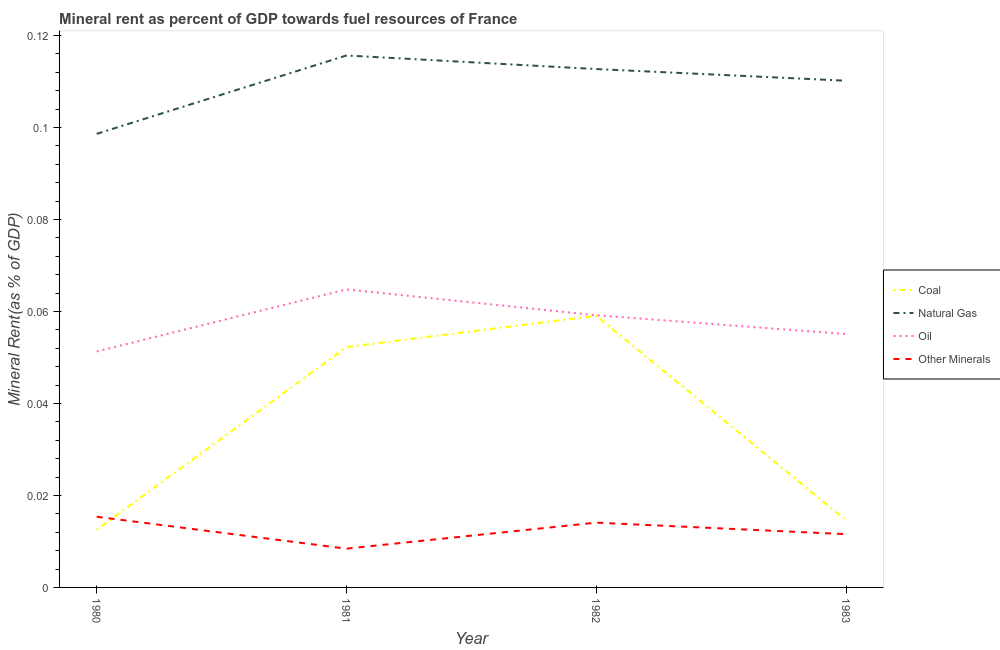How many different coloured lines are there?
Your answer should be compact. 4. Does the line corresponding to coal rent intersect with the line corresponding to oil rent?
Offer a very short reply. No. What is the coal rent in 1983?
Your answer should be compact. 0.01. Across all years, what is the maximum coal rent?
Make the answer very short. 0.06. Across all years, what is the minimum natural gas rent?
Your answer should be compact. 0.1. What is the total natural gas rent in the graph?
Make the answer very short. 0.44. What is the difference between the natural gas rent in 1981 and that in 1982?
Your response must be concise. 0. What is the difference between the natural gas rent in 1982 and the  rent of other minerals in 1981?
Provide a succinct answer. 0.1. What is the average oil rent per year?
Your answer should be very brief. 0.06. In the year 1982, what is the difference between the coal rent and  rent of other minerals?
Make the answer very short. 0.04. In how many years, is the coal rent greater than 0.052000000000000005 %?
Your answer should be compact. 2. What is the ratio of the  rent of other minerals in 1980 to that in 1983?
Provide a short and direct response. 1.33. Is the  rent of other minerals in 1980 less than that in 1983?
Ensure brevity in your answer.  No. What is the difference between the highest and the second highest coal rent?
Offer a very short reply. 0.01. What is the difference between the highest and the lowest coal rent?
Make the answer very short. 0.05. In how many years, is the natural gas rent greater than the average natural gas rent taken over all years?
Offer a very short reply. 3. Is it the case that in every year, the sum of the coal rent and natural gas rent is greater than the oil rent?
Make the answer very short. Yes. Does the coal rent monotonically increase over the years?
Make the answer very short. No. How many years are there in the graph?
Provide a succinct answer. 4. Does the graph contain any zero values?
Your response must be concise. No. Where does the legend appear in the graph?
Offer a terse response. Center right. How many legend labels are there?
Keep it short and to the point. 4. What is the title of the graph?
Ensure brevity in your answer.  Mineral rent as percent of GDP towards fuel resources of France. Does "Management rating" appear as one of the legend labels in the graph?
Provide a short and direct response. No. What is the label or title of the X-axis?
Ensure brevity in your answer.  Year. What is the label or title of the Y-axis?
Keep it short and to the point. Mineral Rent(as % of GDP). What is the Mineral Rent(as % of GDP) in Coal in 1980?
Keep it short and to the point. 0.01. What is the Mineral Rent(as % of GDP) in Natural Gas in 1980?
Make the answer very short. 0.1. What is the Mineral Rent(as % of GDP) of Oil in 1980?
Your response must be concise. 0.05. What is the Mineral Rent(as % of GDP) in Other Minerals in 1980?
Your response must be concise. 0.02. What is the Mineral Rent(as % of GDP) of Coal in 1981?
Provide a short and direct response. 0.05. What is the Mineral Rent(as % of GDP) of Natural Gas in 1981?
Provide a succinct answer. 0.12. What is the Mineral Rent(as % of GDP) in Oil in 1981?
Give a very brief answer. 0.06. What is the Mineral Rent(as % of GDP) of Other Minerals in 1981?
Your answer should be very brief. 0.01. What is the Mineral Rent(as % of GDP) in Coal in 1982?
Your response must be concise. 0.06. What is the Mineral Rent(as % of GDP) of Natural Gas in 1982?
Make the answer very short. 0.11. What is the Mineral Rent(as % of GDP) of Oil in 1982?
Make the answer very short. 0.06. What is the Mineral Rent(as % of GDP) in Other Minerals in 1982?
Your answer should be very brief. 0.01. What is the Mineral Rent(as % of GDP) in Coal in 1983?
Your answer should be very brief. 0.01. What is the Mineral Rent(as % of GDP) in Natural Gas in 1983?
Provide a short and direct response. 0.11. What is the Mineral Rent(as % of GDP) of Oil in 1983?
Provide a short and direct response. 0.06. What is the Mineral Rent(as % of GDP) in Other Minerals in 1983?
Your answer should be compact. 0.01. Across all years, what is the maximum Mineral Rent(as % of GDP) in Coal?
Provide a succinct answer. 0.06. Across all years, what is the maximum Mineral Rent(as % of GDP) of Natural Gas?
Offer a very short reply. 0.12. Across all years, what is the maximum Mineral Rent(as % of GDP) of Oil?
Your response must be concise. 0.06. Across all years, what is the maximum Mineral Rent(as % of GDP) in Other Minerals?
Offer a terse response. 0.02. Across all years, what is the minimum Mineral Rent(as % of GDP) of Coal?
Give a very brief answer. 0.01. Across all years, what is the minimum Mineral Rent(as % of GDP) in Natural Gas?
Keep it short and to the point. 0.1. Across all years, what is the minimum Mineral Rent(as % of GDP) of Oil?
Give a very brief answer. 0.05. Across all years, what is the minimum Mineral Rent(as % of GDP) in Other Minerals?
Keep it short and to the point. 0.01. What is the total Mineral Rent(as % of GDP) of Coal in the graph?
Your answer should be compact. 0.14. What is the total Mineral Rent(as % of GDP) of Natural Gas in the graph?
Keep it short and to the point. 0.44. What is the total Mineral Rent(as % of GDP) of Oil in the graph?
Ensure brevity in your answer.  0.23. What is the total Mineral Rent(as % of GDP) in Other Minerals in the graph?
Give a very brief answer. 0.05. What is the difference between the Mineral Rent(as % of GDP) in Coal in 1980 and that in 1981?
Offer a terse response. -0.04. What is the difference between the Mineral Rent(as % of GDP) of Natural Gas in 1980 and that in 1981?
Offer a very short reply. -0.02. What is the difference between the Mineral Rent(as % of GDP) of Oil in 1980 and that in 1981?
Provide a short and direct response. -0.01. What is the difference between the Mineral Rent(as % of GDP) in Other Minerals in 1980 and that in 1981?
Give a very brief answer. 0.01. What is the difference between the Mineral Rent(as % of GDP) of Coal in 1980 and that in 1982?
Offer a terse response. -0.05. What is the difference between the Mineral Rent(as % of GDP) in Natural Gas in 1980 and that in 1982?
Keep it short and to the point. -0.01. What is the difference between the Mineral Rent(as % of GDP) in Oil in 1980 and that in 1982?
Offer a very short reply. -0.01. What is the difference between the Mineral Rent(as % of GDP) in Other Minerals in 1980 and that in 1982?
Offer a very short reply. 0. What is the difference between the Mineral Rent(as % of GDP) in Coal in 1980 and that in 1983?
Make the answer very short. -0. What is the difference between the Mineral Rent(as % of GDP) in Natural Gas in 1980 and that in 1983?
Your answer should be very brief. -0.01. What is the difference between the Mineral Rent(as % of GDP) in Oil in 1980 and that in 1983?
Offer a terse response. -0. What is the difference between the Mineral Rent(as % of GDP) in Other Minerals in 1980 and that in 1983?
Your response must be concise. 0. What is the difference between the Mineral Rent(as % of GDP) in Coal in 1981 and that in 1982?
Keep it short and to the point. -0.01. What is the difference between the Mineral Rent(as % of GDP) in Natural Gas in 1981 and that in 1982?
Your answer should be compact. 0. What is the difference between the Mineral Rent(as % of GDP) of Oil in 1981 and that in 1982?
Provide a short and direct response. 0.01. What is the difference between the Mineral Rent(as % of GDP) of Other Minerals in 1981 and that in 1982?
Keep it short and to the point. -0.01. What is the difference between the Mineral Rent(as % of GDP) of Coal in 1981 and that in 1983?
Your answer should be very brief. 0.04. What is the difference between the Mineral Rent(as % of GDP) of Natural Gas in 1981 and that in 1983?
Your response must be concise. 0.01. What is the difference between the Mineral Rent(as % of GDP) of Oil in 1981 and that in 1983?
Offer a terse response. 0.01. What is the difference between the Mineral Rent(as % of GDP) in Other Minerals in 1981 and that in 1983?
Provide a succinct answer. -0. What is the difference between the Mineral Rent(as % of GDP) of Coal in 1982 and that in 1983?
Your response must be concise. 0.04. What is the difference between the Mineral Rent(as % of GDP) in Natural Gas in 1982 and that in 1983?
Ensure brevity in your answer.  0. What is the difference between the Mineral Rent(as % of GDP) in Oil in 1982 and that in 1983?
Your response must be concise. 0. What is the difference between the Mineral Rent(as % of GDP) of Other Minerals in 1982 and that in 1983?
Provide a short and direct response. 0. What is the difference between the Mineral Rent(as % of GDP) in Coal in 1980 and the Mineral Rent(as % of GDP) in Natural Gas in 1981?
Make the answer very short. -0.1. What is the difference between the Mineral Rent(as % of GDP) in Coal in 1980 and the Mineral Rent(as % of GDP) in Oil in 1981?
Keep it short and to the point. -0.05. What is the difference between the Mineral Rent(as % of GDP) of Coal in 1980 and the Mineral Rent(as % of GDP) of Other Minerals in 1981?
Your response must be concise. 0. What is the difference between the Mineral Rent(as % of GDP) in Natural Gas in 1980 and the Mineral Rent(as % of GDP) in Oil in 1981?
Keep it short and to the point. 0.03. What is the difference between the Mineral Rent(as % of GDP) of Natural Gas in 1980 and the Mineral Rent(as % of GDP) of Other Minerals in 1981?
Make the answer very short. 0.09. What is the difference between the Mineral Rent(as % of GDP) of Oil in 1980 and the Mineral Rent(as % of GDP) of Other Minerals in 1981?
Provide a succinct answer. 0.04. What is the difference between the Mineral Rent(as % of GDP) of Coal in 1980 and the Mineral Rent(as % of GDP) of Natural Gas in 1982?
Ensure brevity in your answer.  -0.1. What is the difference between the Mineral Rent(as % of GDP) in Coal in 1980 and the Mineral Rent(as % of GDP) in Oil in 1982?
Your answer should be very brief. -0.05. What is the difference between the Mineral Rent(as % of GDP) of Coal in 1980 and the Mineral Rent(as % of GDP) of Other Minerals in 1982?
Provide a short and direct response. -0. What is the difference between the Mineral Rent(as % of GDP) of Natural Gas in 1980 and the Mineral Rent(as % of GDP) of Oil in 1982?
Ensure brevity in your answer.  0.04. What is the difference between the Mineral Rent(as % of GDP) of Natural Gas in 1980 and the Mineral Rent(as % of GDP) of Other Minerals in 1982?
Your answer should be very brief. 0.08. What is the difference between the Mineral Rent(as % of GDP) in Oil in 1980 and the Mineral Rent(as % of GDP) in Other Minerals in 1982?
Your response must be concise. 0.04. What is the difference between the Mineral Rent(as % of GDP) of Coal in 1980 and the Mineral Rent(as % of GDP) of Natural Gas in 1983?
Make the answer very short. -0.1. What is the difference between the Mineral Rent(as % of GDP) in Coal in 1980 and the Mineral Rent(as % of GDP) in Oil in 1983?
Your answer should be compact. -0.04. What is the difference between the Mineral Rent(as % of GDP) in Coal in 1980 and the Mineral Rent(as % of GDP) in Other Minerals in 1983?
Offer a very short reply. 0. What is the difference between the Mineral Rent(as % of GDP) in Natural Gas in 1980 and the Mineral Rent(as % of GDP) in Oil in 1983?
Your response must be concise. 0.04. What is the difference between the Mineral Rent(as % of GDP) of Natural Gas in 1980 and the Mineral Rent(as % of GDP) of Other Minerals in 1983?
Your answer should be compact. 0.09. What is the difference between the Mineral Rent(as % of GDP) in Oil in 1980 and the Mineral Rent(as % of GDP) in Other Minerals in 1983?
Your answer should be compact. 0.04. What is the difference between the Mineral Rent(as % of GDP) in Coal in 1981 and the Mineral Rent(as % of GDP) in Natural Gas in 1982?
Ensure brevity in your answer.  -0.06. What is the difference between the Mineral Rent(as % of GDP) in Coal in 1981 and the Mineral Rent(as % of GDP) in Oil in 1982?
Offer a very short reply. -0.01. What is the difference between the Mineral Rent(as % of GDP) in Coal in 1981 and the Mineral Rent(as % of GDP) in Other Minerals in 1982?
Provide a short and direct response. 0.04. What is the difference between the Mineral Rent(as % of GDP) of Natural Gas in 1981 and the Mineral Rent(as % of GDP) of Oil in 1982?
Give a very brief answer. 0.06. What is the difference between the Mineral Rent(as % of GDP) of Natural Gas in 1981 and the Mineral Rent(as % of GDP) of Other Minerals in 1982?
Offer a terse response. 0.1. What is the difference between the Mineral Rent(as % of GDP) of Oil in 1981 and the Mineral Rent(as % of GDP) of Other Minerals in 1982?
Your response must be concise. 0.05. What is the difference between the Mineral Rent(as % of GDP) in Coal in 1981 and the Mineral Rent(as % of GDP) in Natural Gas in 1983?
Offer a very short reply. -0.06. What is the difference between the Mineral Rent(as % of GDP) of Coal in 1981 and the Mineral Rent(as % of GDP) of Oil in 1983?
Give a very brief answer. -0. What is the difference between the Mineral Rent(as % of GDP) of Coal in 1981 and the Mineral Rent(as % of GDP) of Other Minerals in 1983?
Ensure brevity in your answer.  0.04. What is the difference between the Mineral Rent(as % of GDP) in Natural Gas in 1981 and the Mineral Rent(as % of GDP) in Oil in 1983?
Offer a very short reply. 0.06. What is the difference between the Mineral Rent(as % of GDP) in Natural Gas in 1981 and the Mineral Rent(as % of GDP) in Other Minerals in 1983?
Provide a succinct answer. 0.1. What is the difference between the Mineral Rent(as % of GDP) of Oil in 1981 and the Mineral Rent(as % of GDP) of Other Minerals in 1983?
Your answer should be compact. 0.05. What is the difference between the Mineral Rent(as % of GDP) in Coal in 1982 and the Mineral Rent(as % of GDP) in Natural Gas in 1983?
Give a very brief answer. -0.05. What is the difference between the Mineral Rent(as % of GDP) in Coal in 1982 and the Mineral Rent(as % of GDP) in Oil in 1983?
Give a very brief answer. 0. What is the difference between the Mineral Rent(as % of GDP) in Coal in 1982 and the Mineral Rent(as % of GDP) in Other Minerals in 1983?
Offer a terse response. 0.05. What is the difference between the Mineral Rent(as % of GDP) of Natural Gas in 1982 and the Mineral Rent(as % of GDP) of Oil in 1983?
Give a very brief answer. 0.06. What is the difference between the Mineral Rent(as % of GDP) in Natural Gas in 1982 and the Mineral Rent(as % of GDP) in Other Minerals in 1983?
Your answer should be compact. 0.1. What is the difference between the Mineral Rent(as % of GDP) in Oil in 1982 and the Mineral Rent(as % of GDP) in Other Minerals in 1983?
Ensure brevity in your answer.  0.05. What is the average Mineral Rent(as % of GDP) in Coal per year?
Your answer should be very brief. 0.03. What is the average Mineral Rent(as % of GDP) in Natural Gas per year?
Provide a succinct answer. 0.11. What is the average Mineral Rent(as % of GDP) of Oil per year?
Your answer should be compact. 0.06. What is the average Mineral Rent(as % of GDP) of Other Minerals per year?
Provide a short and direct response. 0.01. In the year 1980, what is the difference between the Mineral Rent(as % of GDP) in Coal and Mineral Rent(as % of GDP) in Natural Gas?
Provide a short and direct response. -0.09. In the year 1980, what is the difference between the Mineral Rent(as % of GDP) in Coal and Mineral Rent(as % of GDP) in Oil?
Offer a terse response. -0.04. In the year 1980, what is the difference between the Mineral Rent(as % of GDP) of Coal and Mineral Rent(as % of GDP) of Other Minerals?
Your answer should be very brief. -0. In the year 1980, what is the difference between the Mineral Rent(as % of GDP) of Natural Gas and Mineral Rent(as % of GDP) of Oil?
Ensure brevity in your answer.  0.05. In the year 1980, what is the difference between the Mineral Rent(as % of GDP) in Natural Gas and Mineral Rent(as % of GDP) in Other Minerals?
Make the answer very short. 0.08. In the year 1980, what is the difference between the Mineral Rent(as % of GDP) in Oil and Mineral Rent(as % of GDP) in Other Minerals?
Ensure brevity in your answer.  0.04. In the year 1981, what is the difference between the Mineral Rent(as % of GDP) of Coal and Mineral Rent(as % of GDP) of Natural Gas?
Provide a short and direct response. -0.06. In the year 1981, what is the difference between the Mineral Rent(as % of GDP) in Coal and Mineral Rent(as % of GDP) in Oil?
Keep it short and to the point. -0.01. In the year 1981, what is the difference between the Mineral Rent(as % of GDP) in Coal and Mineral Rent(as % of GDP) in Other Minerals?
Provide a succinct answer. 0.04. In the year 1981, what is the difference between the Mineral Rent(as % of GDP) in Natural Gas and Mineral Rent(as % of GDP) in Oil?
Offer a terse response. 0.05. In the year 1981, what is the difference between the Mineral Rent(as % of GDP) of Natural Gas and Mineral Rent(as % of GDP) of Other Minerals?
Your answer should be compact. 0.11. In the year 1981, what is the difference between the Mineral Rent(as % of GDP) of Oil and Mineral Rent(as % of GDP) of Other Minerals?
Offer a very short reply. 0.06. In the year 1982, what is the difference between the Mineral Rent(as % of GDP) in Coal and Mineral Rent(as % of GDP) in Natural Gas?
Give a very brief answer. -0.05. In the year 1982, what is the difference between the Mineral Rent(as % of GDP) in Coal and Mineral Rent(as % of GDP) in Oil?
Your answer should be very brief. -0. In the year 1982, what is the difference between the Mineral Rent(as % of GDP) in Coal and Mineral Rent(as % of GDP) in Other Minerals?
Provide a short and direct response. 0.04. In the year 1982, what is the difference between the Mineral Rent(as % of GDP) of Natural Gas and Mineral Rent(as % of GDP) of Oil?
Your answer should be compact. 0.05. In the year 1982, what is the difference between the Mineral Rent(as % of GDP) in Natural Gas and Mineral Rent(as % of GDP) in Other Minerals?
Provide a succinct answer. 0.1. In the year 1982, what is the difference between the Mineral Rent(as % of GDP) of Oil and Mineral Rent(as % of GDP) of Other Minerals?
Keep it short and to the point. 0.05. In the year 1983, what is the difference between the Mineral Rent(as % of GDP) of Coal and Mineral Rent(as % of GDP) of Natural Gas?
Offer a very short reply. -0.1. In the year 1983, what is the difference between the Mineral Rent(as % of GDP) of Coal and Mineral Rent(as % of GDP) of Oil?
Offer a terse response. -0.04. In the year 1983, what is the difference between the Mineral Rent(as % of GDP) in Coal and Mineral Rent(as % of GDP) in Other Minerals?
Make the answer very short. 0. In the year 1983, what is the difference between the Mineral Rent(as % of GDP) of Natural Gas and Mineral Rent(as % of GDP) of Oil?
Give a very brief answer. 0.06. In the year 1983, what is the difference between the Mineral Rent(as % of GDP) of Natural Gas and Mineral Rent(as % of GDP) of Other Minerals?
Keep it short and to the point. 0.1. In the year 1983, what is the difference between the Mineral Rent(as % of GDP) of Oil and Mineral Rent(as % of GDP) of Other Minerals?
Keep it short and to the point. 0.04. What is the ratio of the Mineral Rent(as % of GDP) of Coal in 1980 to that in 1981?
Your response must be concise. 0.24. What is the ratio of the Mineral Rent(as % of GDP) in Natural Gas in 1980 to that in 1981?
Provide a succinct answer. 0.85. What is the ratio of the Mineral Rent(as % of GDP) in Oil in 1980 to that in 1981?
Keep it short and to the point. 0.79. What is the ratio of the Mineral Rent(as % of GDP) of Other Minerals in 1980 to that in 1981?
Your answer should be very brief. 1.82. What is the ratio of the Mineral Rent(as % of GDP) in Coal in 1980 to that in 1982?
Your response must be concise. 0.21. What is the ratio of the Mineral Rent(as % of GDP) in Natural Gas in 1980 to that in 1982?
Offer a very short reply. 0.88. What is the ratio of the Mineral Rent(as % of GDP) in Oil in 1980 to that in 1982?
Make the answer very short. 0.87. What is the ratio of the Mineral Rent(as % of GDP) in Other Minerals in 1980 to that in 1982?
Your answer should be very brief. 1.09. What is the ratio of the Mineral Rent(as % of GDP) in Coal in 1980 to that in 1983?
Make the answer very short. 0.86. What is the ratio of the Mineral Rent(as % of GDP) of Natural Gas in 1980 to that in 1983?
Your answer should be very brief. 0.9. What is the ratio of the Mineral Rent(as % of GDP) of Oil in 1980 to that in 1983?
Your answer should be compact. 0.93. What is the ratio of the Mineral Rent(as % of GDP) of Other Minerals in 1980 to that in 1983?
Your answer should be very brief. 1.33. What is the ratio of the Mineral Rent(as % of GDP) of Coal in 1981 to that in 1982?
Give a very brief answer. 0.88. What is the ratio of the Mineral Rent(as % of GDP) of Natural Gas in 1981 to that in 1982?
Offer a very short reply. 1.03. What is the ratio of the Mineral Rent(as % of GDP) in Oil in 1981 to that in 1982?
Provide a succinct answer. 1.09. What is the ratio of the Mineral Rent(as % of GDP) in Other Minerals in 1981 to that in 1982?
Provide a succinct answer. 0.6. What is the ratio of the Mineral Rent(as % of GDP) of Coal in 1981 to that in 1983?
Provide a short and direct response. 3.57. What is the ratio of the Mineral Rent(as % of GDP) of Natural Gas in 1981 to that in 1983?
Provide a succinct answer. 1.05. What is the ratio of the Mineral Rent(as % of GDP) of Oil in 1981 to that in 1983?
Provide a succinct answer. 1.18. What is the ratio of the Mineral Rent(as % of GDP) of Other Minerals in 1981 to that in 1983?
Provide a succinct answer. 0.73. What is the ratio of the Mineral Rent(as % of GDP) in Coal in 1982 to that in 1983?
Provide a short and direct response. 4.04. What is the ratio of the Mineral Rent(as % of GDP) in Oil in 1982 to that in 1983?
Make the answer very short. 1.07. What is the ratio of the Mineral Rent(as % of GDP) in Other Minerals in 1982 to that in 1983?
Your answer should be very brief. 1.22. What is the difference between the highest and the second highest Mineral Rent(as % of GDP) in Coal?
Your answer should be compact. 0.01. What is the difference between the highest and the second highest Mineral Rent(as % of GDP) of Natural Gas?
Your answer should be very brief. 0. What is the difference between the highest and the second highest Mineral Rent(as % of GDP) in Oil?
Make the answer very short. 0.01. What is the difference between the highest and the second highest Mineral Rent(as % of GDP) in Other Minerals?
Your answer should be compact. 0. What is the difference between the highest and the lowest Mineral Rent(as % of GDP) in Coal?
Provide a succinct answer. 0.05. What is the difference between the highest and the lowest Mineral Rent(as % of GDP) of Natural Gas?
Ensure brevity in your answer.  0.02. What is the difference between the highest and the lowest Mineral Rent(as % of GDP) in Oil?
Your answer should be compact. 0.01. What is the difference between the highest and the lowest Mineral Rent(as % of GDP) in Other Minerals?
Your response must be concise. 0.01. 